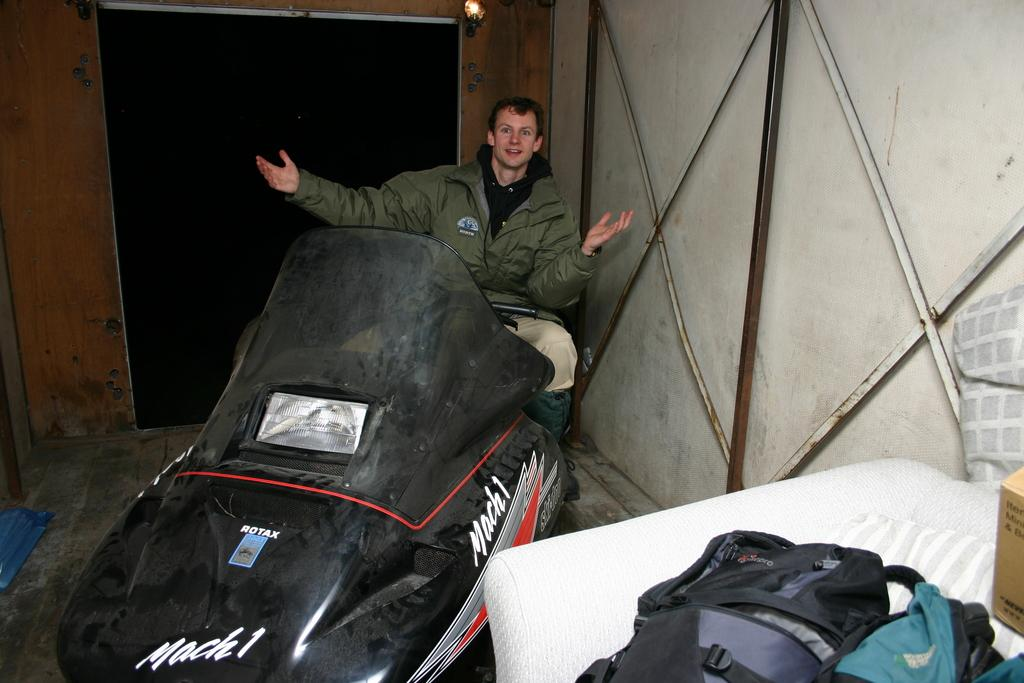What is on the floor in the image? There is a vehicle on the floor in the image. Who is sitting on the vehicle? A person is sitting on the seat of the vehicle. What can be seen in the background of the image? There are electric lights, walls, and bags in the background of the image. What rate is the carpenter charging for their services in the image? There is no carpenter or any mention of services or charges in the image. 